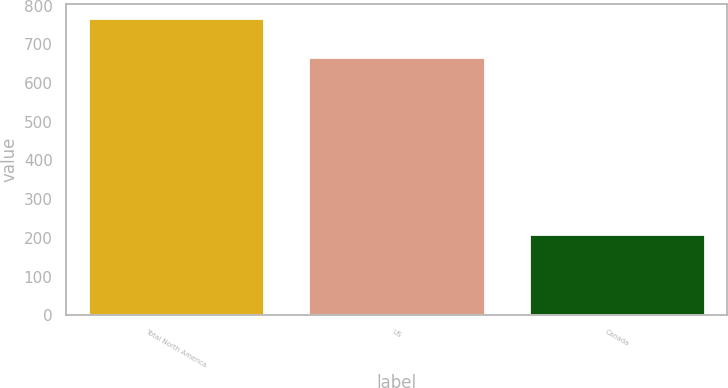<chart> <loc_0><loc_0><loc_500><loc_500><bar_chart><fcel>Total North America<fcel>US<fcel>Canada<nl><fcel>767.2<fcel>668.2<fcel>209.3<nl></chart> 